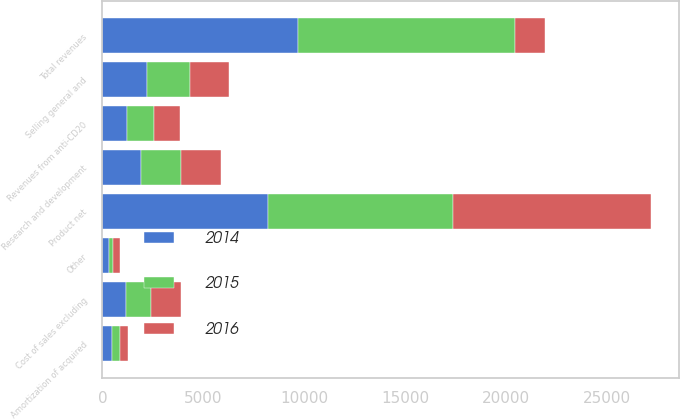Convert chart to OTSL. <chart><loc_0><loc_0><loc_500><loc_500><stacked_bar_chart><ecel><fcel>Product net<fcel>Revenues from anti-CD20<fcel>Other<fcel>Total revenues<fcel>Cost of sales excluding<fcel>Research and development<fcel>Selling general and<fcel>Amortization of acquired<nl><fcel>2016<fcel>9817.9<fcel>1314.5<fcel>316.4<fcel>1478.7<fcel>1478.7<fcel>1973.3<fcel>1947.9<fcel>385.6<nl><fcel>2015<fcel>9188.5<fcel>1339.2<fcel>236.1<fcel>10763.8<fcel>1240.4<fcel>2012.8<fcel>2113.1<fcel>382.6<nl><fcel>2014<fcel>8203.4<fcel>1195.4<fcel>304.5<fcel>9703.3<fcel>1171<fcel>1893.4<fcel>2232.3<fcel>489.8<nl></chart> 